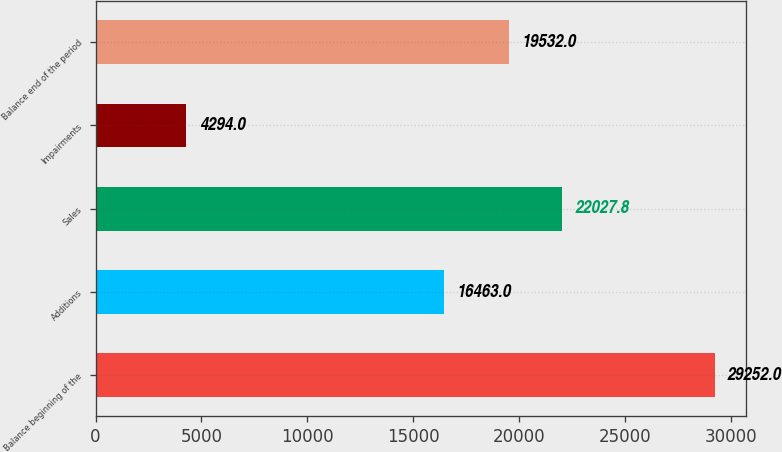Convert chart to OTSL. <chart><loc_0><loc_0><loc_500><loc_500><bar_chart><fcel>Balance beginning of the<fcel>Additions<fcel>Sales<fcel>Impairments<fcel>Balance end of the period<nl><fcel>29252<fcel>16463<fcel>22027.8<fcel>4294<fcel>19532<nl></chart> 